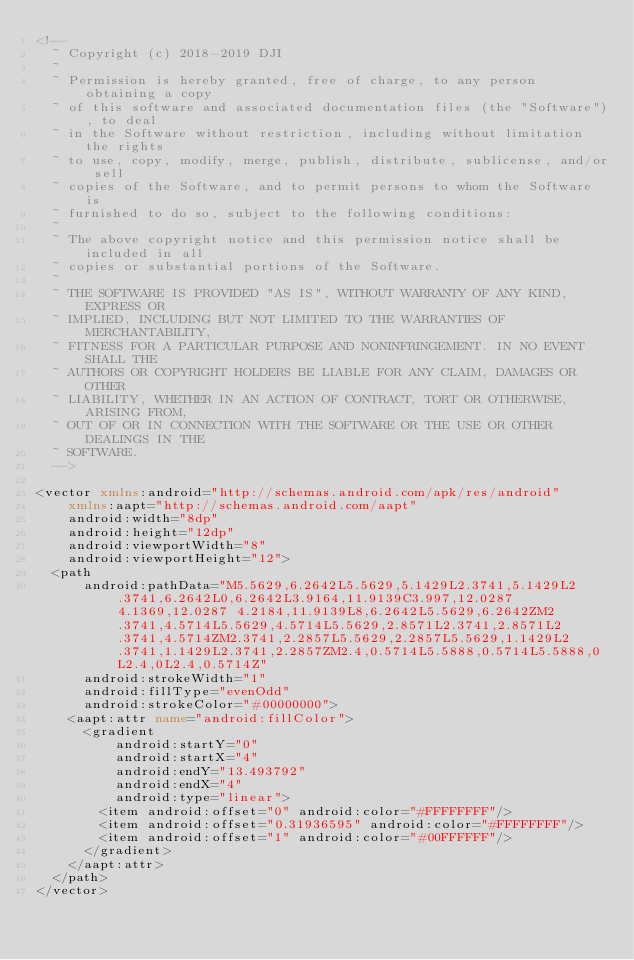<code> <loc_0><loc_0><loc_500><loc_500><_XML_><!--
  ~ Copyright (c) 2018-2019 DJI
  ~
  ~ Permission is hereby granted, free of charge, to any person obtaining a copy
  ~ of this software and associated documentation files (the "Software"), to deal
  ~ in the Software without restriction, including without limitation the rights
  ~ to use, copy, modify, merge, publish, distribute, sublicense, and/or sell
  ~ copies of the Software, and to permit persons to whom the Software is
  ~ furnished to do so, subject to the following conditions:
  ~
  ~ The above copyright notice and this permission notice shall be included in all
  ~ copies or substantial portions of the Software.
  ~
  ~ THE SOFTWARE IS PROVIDED "AS IS", WITHOUT WARRANTY OF ANY KIND, EXPRESS OR
  ~ IMPLIED, INCLUDING BUT NOT LIMITED TO THE WARRANTIES OF MERCHANTABILITY,
  ~ FITNESS FOR A PARTICULAR PURPOSE AND NONINFRINGEMENT. IN NO EVENT SHALL THE
  ~ AUTHORS OR COPYRIGHT HOLDERS BE LIABLE FOR ANY CLAIM, DAMAGES OR OTHER
  ~ LIABILITY, WHETHER IN AN ACTION OF CONTRACT, TORT OR OTHERWISE, ARISING FROM,
  ~ OUT OF OR IN CONNECTION WITH THE SOFTWARE OR THE USE OR OTHER DEALINGS IN THE
  ~ SOFTWARE.
  -->

<vector xmlns:android="http://schemas.android.com/apk/res/android"
    xmlns:aapt="http://schemas.android.com/aapt"
    android:width="8dp"
    android:height="12dp"
    android:viewportWidth="8"
    android:viewportHeight="12">
  <path
      android:pathData="M5.5629,6.2642L5.5629,5.1429L2.3741,5.1429L2.3741,6.2642L0,6.2642L3.9164,11.9139C3.997,12.0287 4.1369,12.0287 4.2184,11.9139L8,6.2642L5.5629,6.2642ZM2.3741,4.5714L5.5629,4.5714L5.5629,2.8571L2.3741,2.8571L2.3741,4.5714ZM2.3741,2.2857L5.5629,2.2857L5.5629,1.1429L2.3741,1.1429L2.3741,2.2857ZM2.4,0.5714L5.5888,0.5714L5.5888,0L2.4,0L2.4,0.5714Z"
      android:strokeWidth="1"
      android:fillType="evenOdd"
      android:strokeColor="#00000000">
    <aapt:attr name="android:fillColor">
      <gradient 
          android:startY="0"
          android:startX="4"
          android:endY="13.493792"
          android:endX="4"
          android:type="linear">
        <item android:offset="0" android:color="#FFFFFFFF"/>
        <item android:offset="0.31936595" android:color="#FFFFFFFF"/>
        <item android:offset="1" android:color="#00FFFFFF"/>
      </gradient>
    </aapt:attr>
  </path>
</vector>
</code> 